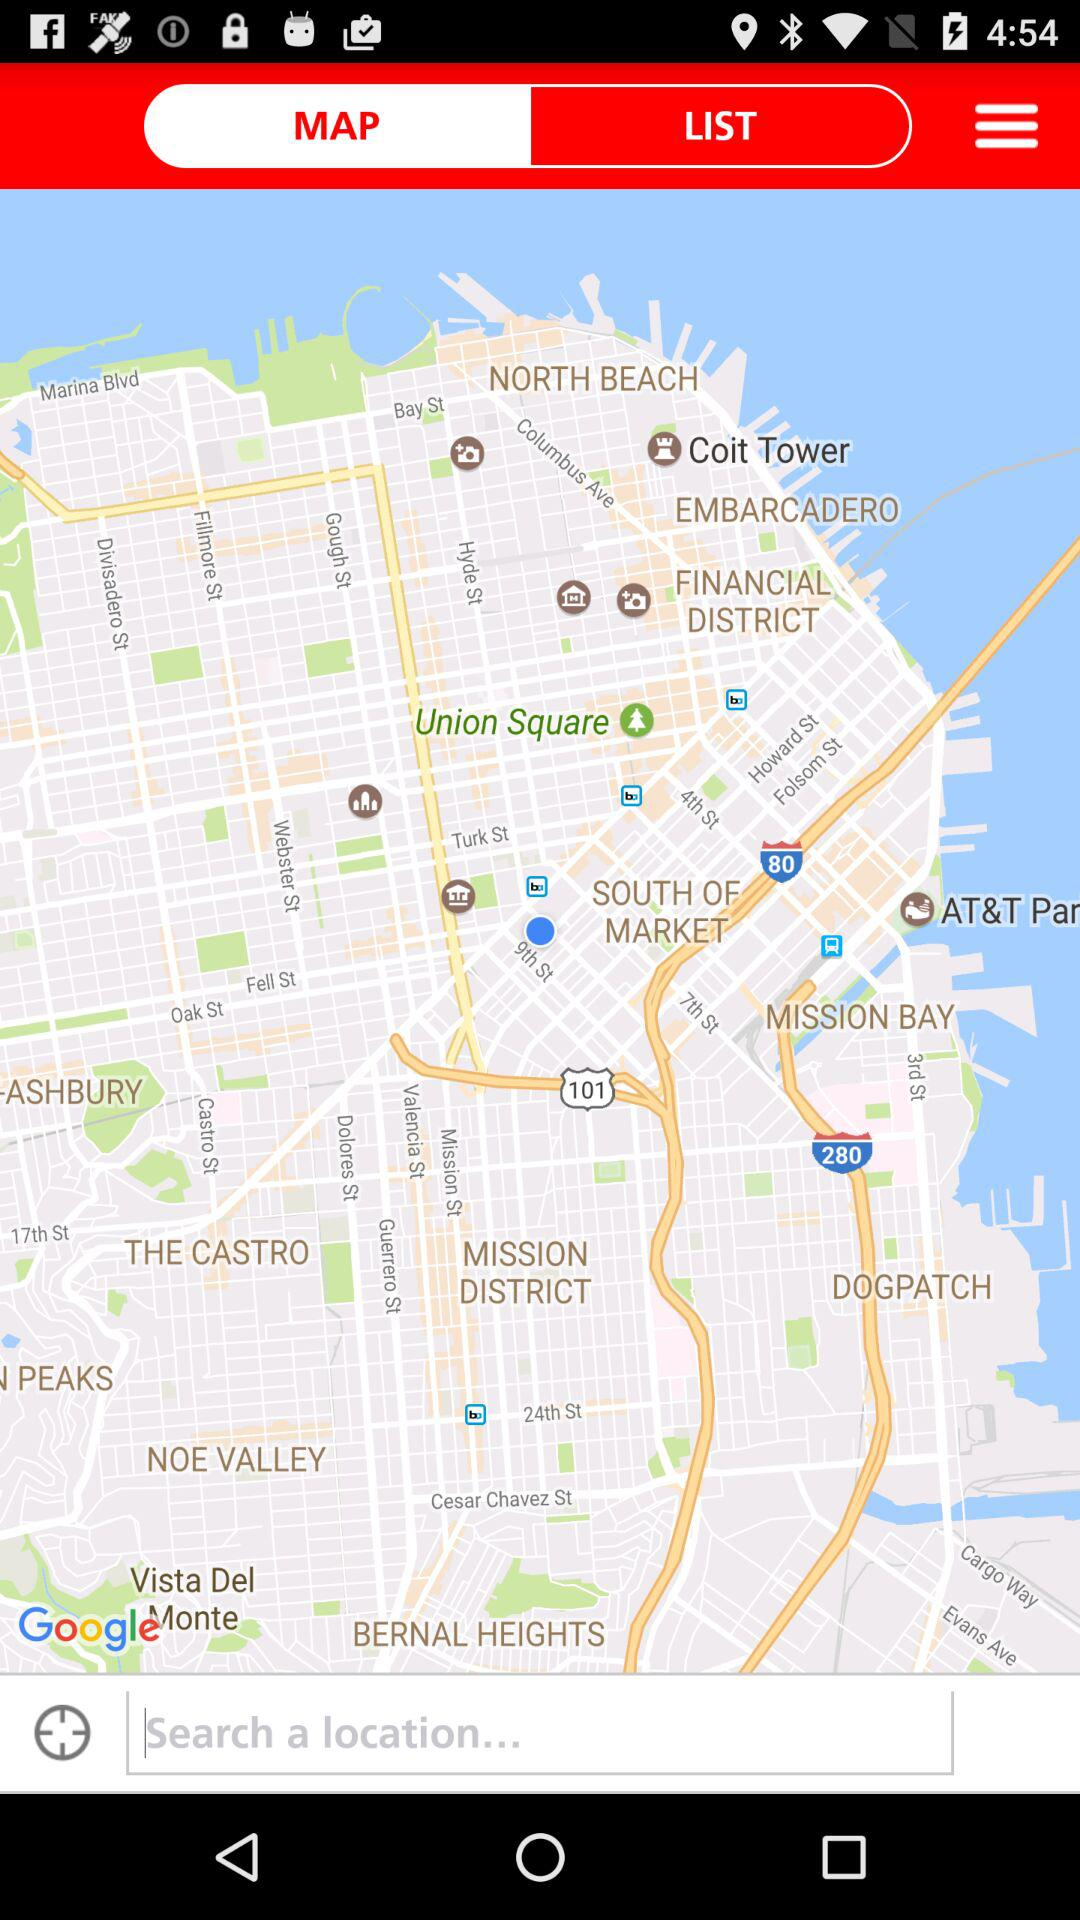Which tab is selected? The selected tab is "MAP". 